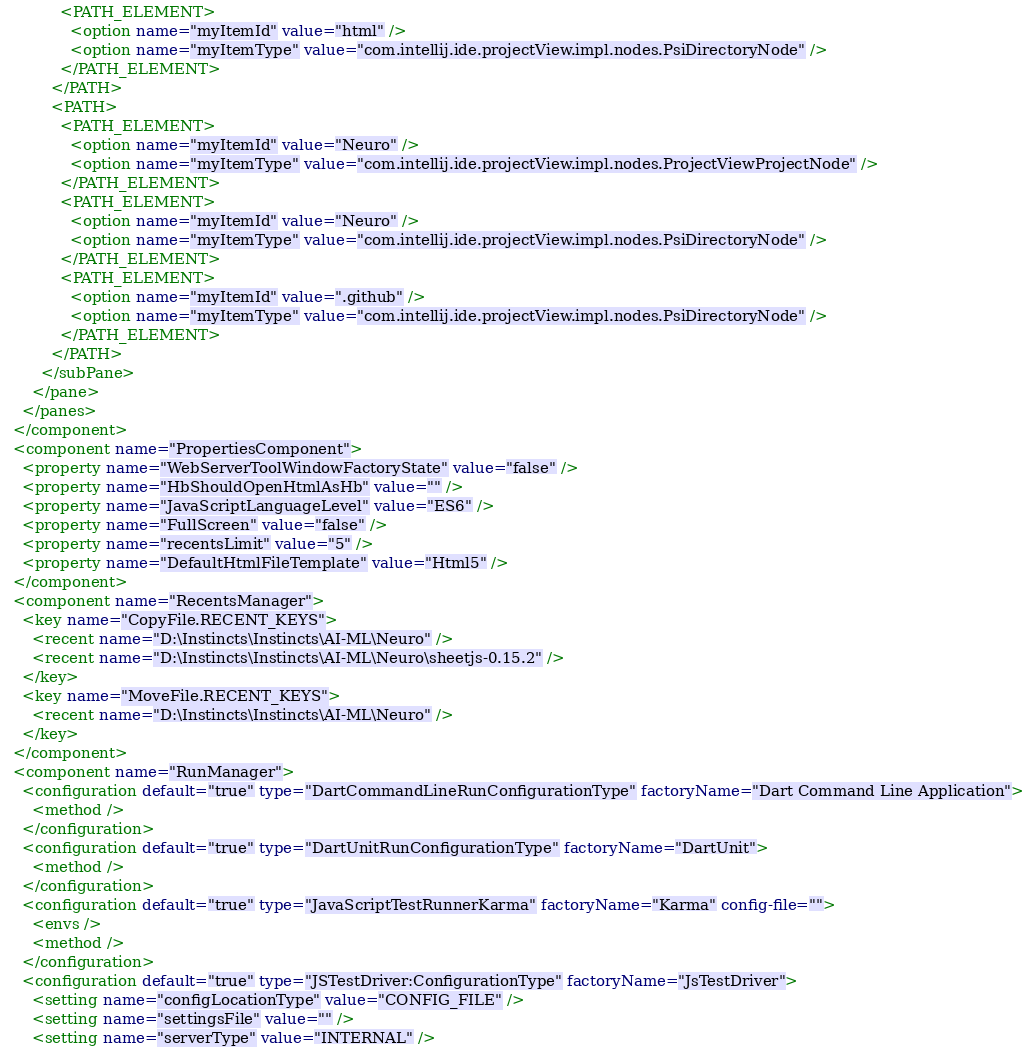Convert code to text. <code><loc_0><loc_0><loc_500><loc_500><_XML_>            <PATH_ELEMENT>
              <option name="myItemId" value="html" />
              <option name="myItemType" value="com.intellij.ide.projectView.impl.nodes.PsiDirectoryNode" />
            </PATH_ELEMENT>
          </PATH>
          <PATH>
            <PATH_ELEMENT>
              <option name="myItemId" value="Neuro" />
              <option name="myItemType" value="com.intellij.ide.projectView.impl.nodes.ProjectViewProjectNode" />
            </PATH_ELEMENT>
            <PATH_ELEMENT>
              <option name="myItemId" value="Neuro" />
              <option name="myItemType" value="com.intellij.ide.projectView.impl.nodes.PsiDirectoryNode" />
            </PATH_ELEMENT>
            <PATH_ELEMENT>
              <option name="myItemId" value=".github" />
              <option name="myItemType" value="com.intellij.ide.projectView.impl.nodes.PsiDirectoryNode" />
            </PATH_ELEMENT>
          </PATH>
        </subPane>
      </pane>
    </panes>
  </component>
  <component name="PropertiesComponent">
    <property name="WebServerToolWindowFactoryState" value="false" />
    <property name="HbShouldOpenHtmlAsHb" value="" />
    <property name="JavaScriptLanguageLevel" value="ES6" />
    <property name="FullScreen" value="false" />
    <property name="recentsLimit" value="5" />
    <property name="DefaultHtmlFileTemplate" value="Html5" />
  </component>
  <component name="RecentsManager">
    <key name="CopyFile.RECENT_KEYS">
      <recent name="D:\Instincts\Instincts\AI-ML\Neuro" />
      <recent name="D:\Instincts\Instincts\AI-ML\Neuro\sheetjs-0.15.2" />
    </key>
    <key name="MoveFile.RECENT_KEYS">
      <recent name="D:\Instincts\Instincts\AI-ML\Neuro" />
    </key>
  </component>
  <component name="RunManager">
    <configuration default="true" type="DartCommandLineRunConfigurationType" factoryName="Dart Command Line Application">
      <method />
    </configuration>
    <configuration default="true" type="DartUnitRunConfigurationType" factoryName="DartUnit">
      <method />
    </configuration>
    <configuration default="true" type="JavaScriptTestRunnerKarma" factoryName="Karma" config-file="">
      <envs />
      <method />
    </configuration>
    <configuration default="true" type="JSTestDriver:ConfigurationType" factoryName="JsTestDriver">
      <setting name="configLocationType" value="CONFIG_FILE" />
      <setting name="settingsFile" value="" />
      <setting name="serverType" value="INTERNAL" /></code> 